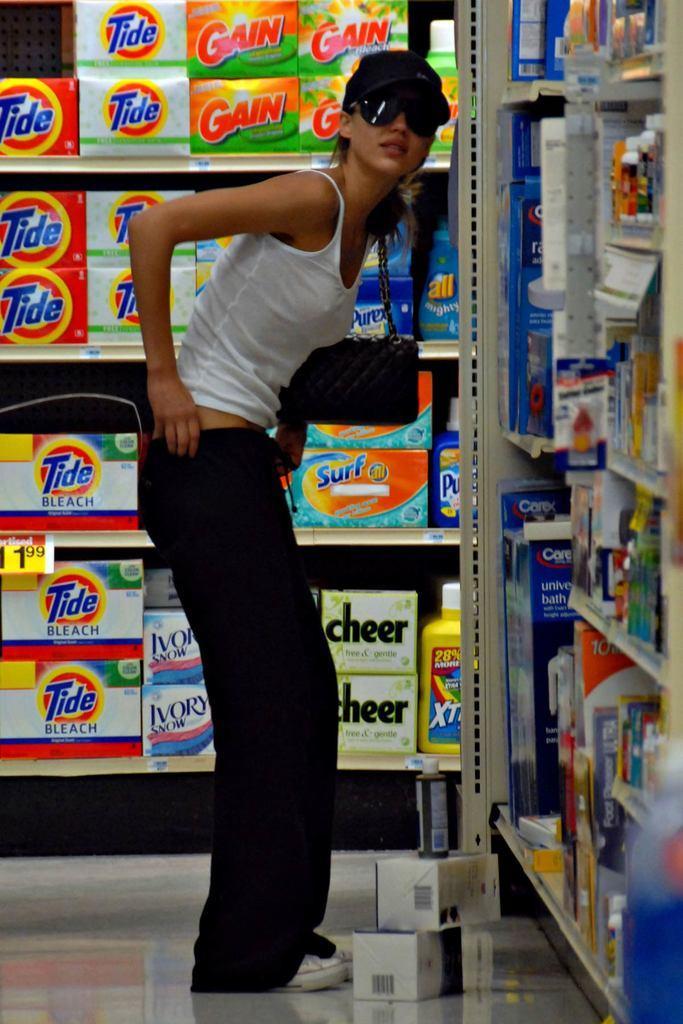Can you describe this image briefly? This image is taken indoors. At the bottom of the image there is a floor. In the middle of the image a girl is standing on the floor. In the background there is a rack with many boxes and a few bottles. On the right side of the image there is another rack with many things. 